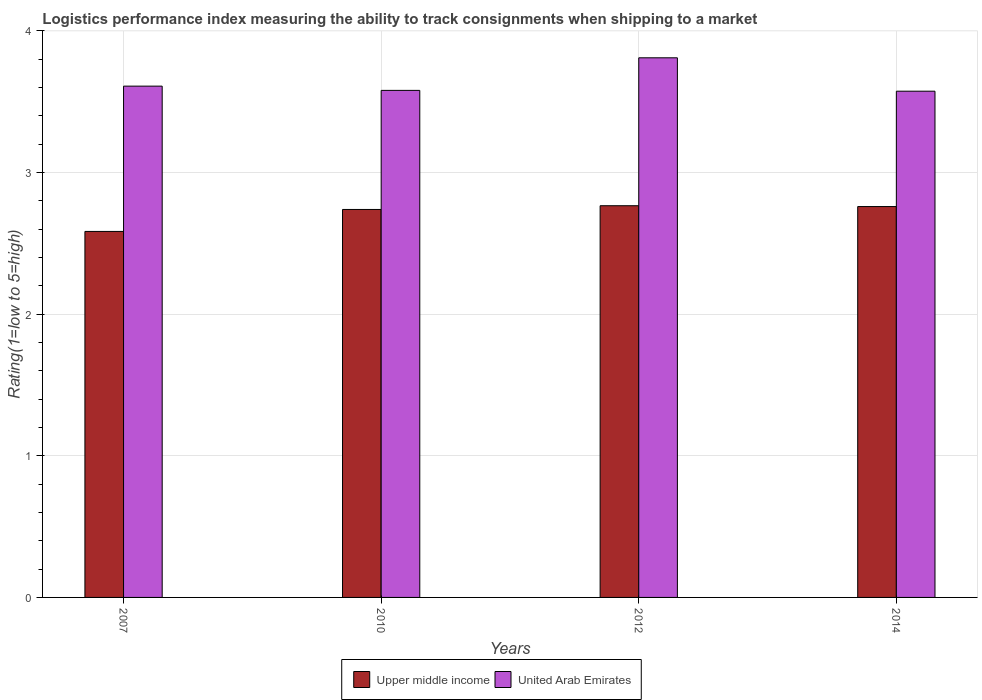How many groups of bars are there?
Make the answer very short. 4. Are the number of bars per tick equal to the number of legend labels?
Provide a succinct answer. Yes. Are the number of bars on each tick of the X-axis equal?
Offer a terse response. Yes. How many bars are there on the 3rd tick from the left?
Make the answer very short. 2. How many bars are there on the 2nd tick from the right?
Offer a terse response. 2. What is the label of the 2nd group of bars from the left?
Ensure brevity in your answer.  2010. In how many cases, is the number of bars for a given year not equal to the number of legend labels?
Offer a very short reply. 0. What is the Logistic performance index in Upper middle income in 2007?
Keep it short and to the point. 2.58. Across all years, what is the maximum Logistic performance index in United Arab Emirates?
Your response must be concise. 3.81. Across all years, what is the minimum Logistic performance index in Upper middle income?
Provide a succinct answer. 2.58. In which year was the Logistic performance index in United Arab Emirates minimum?
Provide a short and direct response. 2014. What is the total Logistic performance index in Upper middle income in the graph?
Ensure brevity in your answer.  10.85. What is the difference between the Logistic performance index in Upper middle income in 2007 and that in 2012?
Your response must be concise. -0.18. What is the difference between the Logistic performance index in United Arab Emirates in 2007 and the Logistic performance index in Upper middle income in 2012?
Your answer should be compact. 0.84. What is the average Logistic performance index in Upper middle income per year?
Offer a terse response. 2.71. In the year 2014, what is the difference between the Logistic performance index in United Arab Emirates and Logistic performance index in Upper middle income?
Provide a short and direct response. 0.81. What is the ratio of the Logistic performance index in Upper middle income in 2007 to that in 2012?
Your response must be concise. 0.93. What is the difference between the highest and the second highest Logistic performance index in United Arab Emirates?
Ensure brevity in your answer.  0.2. What is the difference between the highest and the lowest Logistic performance index in United Arab Emirates?
Give a very brief answer. 0.24. What does the 1st bar from the left in 2007 represents?
Your answer should be very brief. Upper middle income. What does the 2nd bar from the right in 2007 represents?
Offer a very short reply. Upper middle income. How many bars are there?
Give a very brief answer. 8. How many years are there in the graph?
Your response must be concise. 4. What is the difference between two consecutive major ticks on the Y-axis?
Make the answer very short. 1. Does the graph contain grids?
Your response must be concise. Yes. Where does the legend appear in the graph?
Keep it short and to the point. Bottom center. How many legend labels are there?
Your response must be concise. 2. What is the title of the graph?
Make the answer very short. Logistics performance index measuring the ability to track consignments when shipping to a market. What is the label or title of the Y-axis?
Your answer should be compact. Rating(1=low to 5=high). What is the Rating(1=low to 5=high) of Upper middle income in 2007?
Your answer should be compact. 2.58. What is the Rating(1=low to 5=high) of United Arab Emirates in 2007?
Provide a short and direct response. 3.61. What is the Rating(1=low to 5=high) of Upper middle income in 2010?
Keep it short and to the point. 2.74. What is the Rating(1=low to 5=high) in United Arab Emirates in 2010?
Ensure brevity in your answer.  3.58. What is the Rating(1=low to 5=high) of Upper middle income in 2012?
Ensure brevity in your answer.  2.77. What is the Rating(1=low to 5=high) of United Arab Emirates in 2012?
Your answer should be compact. 3.81. What is the Rating(1=low to 5=high) in Upper middle income in 2014?
Offer a very short reply. 2.76. What is the Rating(1=low to 5=high) in United Arab Emirates in 2014?
Ensure brevity in your answer.  3.57. Across all years, what is the maximum Rating(1=low to 5=high) in Upper middle income?
Give a very brief answer. 2.77. Across all years, what is the maximum Rating(1=low to 5=high) of United Arab Emirates?
Provide a succinct answer. 3.81. Across all years, what is the minimum Rating(1=low to 5=high) of Upper middle income?
Give a very brief answer. 2.58. Across all years, what is the minimum Rating(1=low to 5=high) in United Arab Emirates?
Provide a short and direct response. 3.57. What is the total Rating(1=low to 5=high) in Upper middle income in the graph?
Keep it short and to the point. 10.85. What is the total Rating(1=low to 5=high) of United Arab Emirates in the graph?
Give a very brief answer. 14.57. What is the difference between the Rating(1=low to 5=high) in Upper middle income in 2007 and that in 2010?
Make the answer very short. -0.16. What is the difference between the Rating(1=low to 5=high) of Upper middle income in 2007 and that in 2012?
Ensure brevity in your answer.  -0.18. What is the difference between the Rating(1=low to 5=high) of Upper middle income in 2007 and that in 2014?
Your answer should be very brief. -0.18. What is the difference between the Rating(1=low to 5=high) in United Arab Emirates in 2007 and that in 2014?
Provide a succinct answer. 0.04. What is the difference between the Rating(1=low to 5=high) in Upper middle income in 2010 and that in 2012?
Give a very brief answer. -0.03. What is the difference between the Rating(1=low to 5=high) in United Arab Emirates in 2010 and that in 2012?
Ensure brevity in your answer.  -0.23. What is the difference between the Rating(1=low to 5=high) in Upper middle income in 2010 and that in 2014?
Ensure brevity in your answer.  -0.02. What is the difference between the Rating(1=low to 5=high) in United Arab Emirates in 2010 and that in 2014?
Ensure brevity in your answer.  0.01. What is the difference between the Rating(1=low to 5=high) in Upper middle income in 2012 and that in 2014?
Your answer should be compact. 0.01. What is the difference between the Rating(1=low to 5=high) of United Arab Emirates in 2012 and that in 2014?
Keep it short and to the point. 0.24. What is the difference between the Rating(1=low to 5=high) of Upper middle income in 2007 and the Rating(1=low to 5=high) of United Arab Emirates in 2010?
Your answer should be compact. -1. What is the difference between the Rating(1=low to 5=high) in Upper middle income in 2007 and the Rating(1=low to 5=high) in United Arab Emirates in 2012?
Your answer should be very brief. -1.23. What is the difference between the Rating(1=low to 5=high) of Upper middle income in 2007 and the Rating(1=low to 5=high) of United Arab Emirates in 2014?
Offer a terse response. -0.99. What is the difference between the Rating(1=low to 5=high) of Upper middle income in 2010 and the Rating(1=low to 5=high) of United Arab Emirates in 2012?
Ensure brevity in your answer.  -1.07. What is the difference between the Rating(1=low to 5=high) of Upper middle income in 2010 and the Rating(1=low to 5=high) of United Arab Emirates in 2014?
Give a very brief answer. -0.83. What is the difference between the Rating(1=low to 5=high) of Upper middle income in 2012 and the Rating(1=low to 5=high) of United Arab Emirates in 2014?
Provide a succinct answer. -0.81. What is the average Rating(1=low to 5=high) in Upper middle income per year?
Offer a terse response. 2.71. What is the average Rating(1=low to 5=high) in United Arab Emirates per year?
Make the answer very short. 3.64. In the year 2007, what is the difference between the Rating(1=low to 5=high) of Upper middle income and Rating(1=low to 5=high) of United Arab Emirates?
Make the answer very short. -1.03. In the year 2010, what is the difference between the Rating(1=low to 5=high) in Upper middle income and Rating(1=low to 5=high) in United Arab Emirates?
Provide a succinct answer. -0.84. In the year 2012, what is the difference between the Rating(1=low to 5=high) in Upper middle income and Rating(1=low to 5=high) in United Arab Emirates?
Provide a short and direct response. -1.04. In the year 2014, what is the difference between the Rating(1=low to 5=high) in Upper middle income and Rating(1=low to 5=high) in United Arab Emirates?
Keep it short and to the point. -0.81. What is the ratio of the Rating(1=low to 5=high) of Upper middle income in 2007 to that in 2010?
Your response must be concise. 0.94. What is the ratio of the Rating(1=low to 5=high) in United Arab Emirates in 2007 to that in 2010?
Ensure brevity in your answer.  1.01. What is the ratio of the Rating(1=low to 5=high) in Upper middle income in 2007 to that in 2012?
Offer a very short reply. 0.93. What is the ratio of the Rating(1=low to 5=high) in United Arab Emirates in 2007 to that in 2012?
Ensure brevity in your answer.  0.95. What is the ratio of the Rating(1=low to 5=high) of Upper middle income in 2007 to that in 2014?
Provide a succinct answer. 0.94. What is the ratio of the Rating(1=low to 5=high) in Upper middle income in 2010 to that in 2012?
Give a very brief answer. 0.99. What is the ratio of the Rating(1=low to 5=high) of United Arab Emirates in 2010 to that in 2012?
Offer a terse response. 0.94. What is the ratio of the Rating(1=low to 5=high) of United Arab Emirates in 2012 to that in 2014?
Give a very brief answer. 1.07. What is the difference between the highest and the second highest Rating(1=low to 5=high) in Upper middle income?
Keep it short and to the point. 0.01. What is the difference between the highest and the lowest Rating(1=low to 5=high) in Upper middle income?
Your answer should be very brief. 0.18. What is the difference between the highest and the lowest Rating(1=low to 5=high) in United Arab Emirates?
Your answer should be very brief. 0.24. 